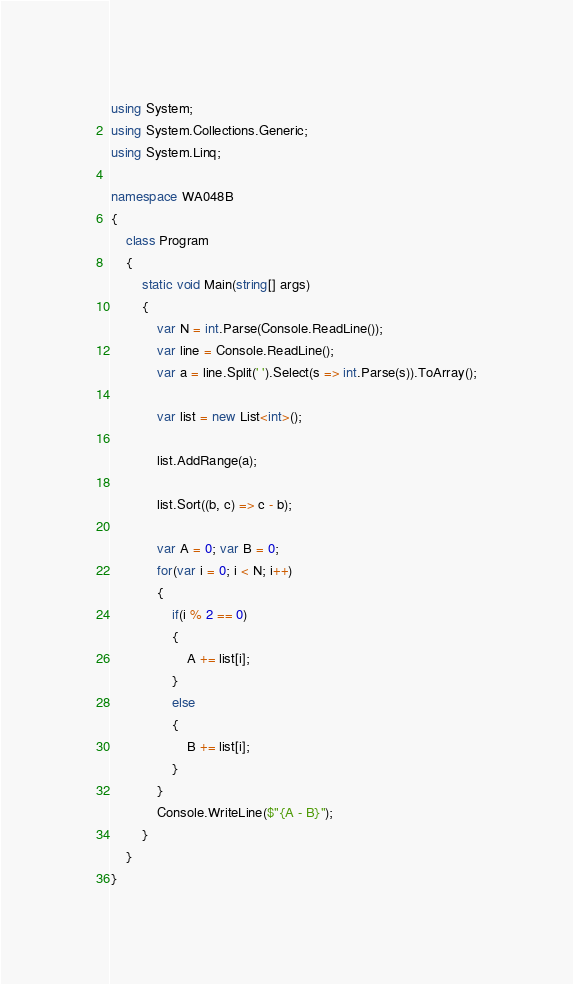Convert code to text. <code><loc_0><loc_0><loc_500><loc_500><_C#_>using System;
using System.Collections.Generic;
using System.Linq;

namespace WA048B
{
    class Program
    {
        static void Main(string[] args)
        {
            var N = int.Parse(Console.ReadLine());
            var line = Console.ReadLine();
            var a = line.Split(' ').Select(s => int.Parse(s)).ToArray();

            var list = new List<int>();

            list.AddRange(a);

            list.Sort((b, c) => c - b);

            var A = 0; var B = 0;
            for(var i = 0; i < N; i++)
            {
                if(i % 2 == 0)
                {
                    A += list[i];
                }
                else
                {
                    B += list[i];
                }
            }
            Console.WriteLine($"{A - B}");
        }
    }
}
</code> 